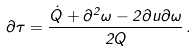Convert formula to latex. <formula><loc_0><loc_0><loc_500><loc_500>\partial \tau = \frac { \dot { Q } + \partial ^ { 2 } \omega - 2 \partial u \partial \omega } { 2 Q } \, .</formula> 